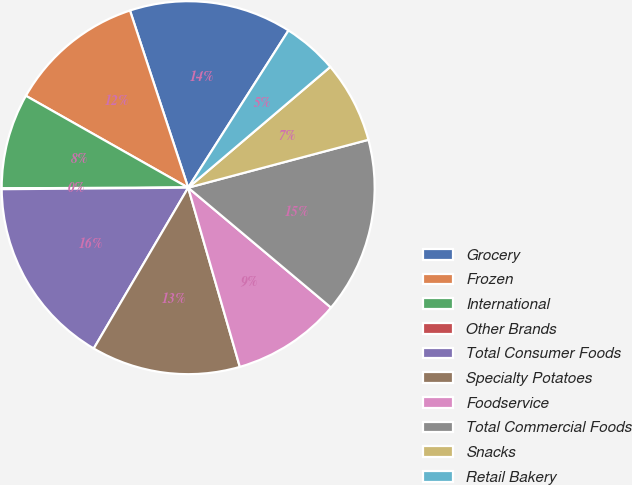Convert chart to OTSL. <chart><loc_0><loc_0><loc_500><loc_500><pie_chart><fcel>Grocery<fcel>Frozen<fcel>International<fcel>Other Brands<fcel>Total Consumer Foods<fcel>Specialty Potatoes<fcel>Foodservice<fcel>Total Commercial Foods<fcel>Snacks<fcel>Retail Bakery<nl><fcel>14.09%<fcel>11.75%<fcel>8.25%<fcel>0.08%<fcel>16.42%<fcel>12.92%<fcel>9.42%<fcel>15.25%<fcel>7.08%<fcel>4.75%<nl></chart> 